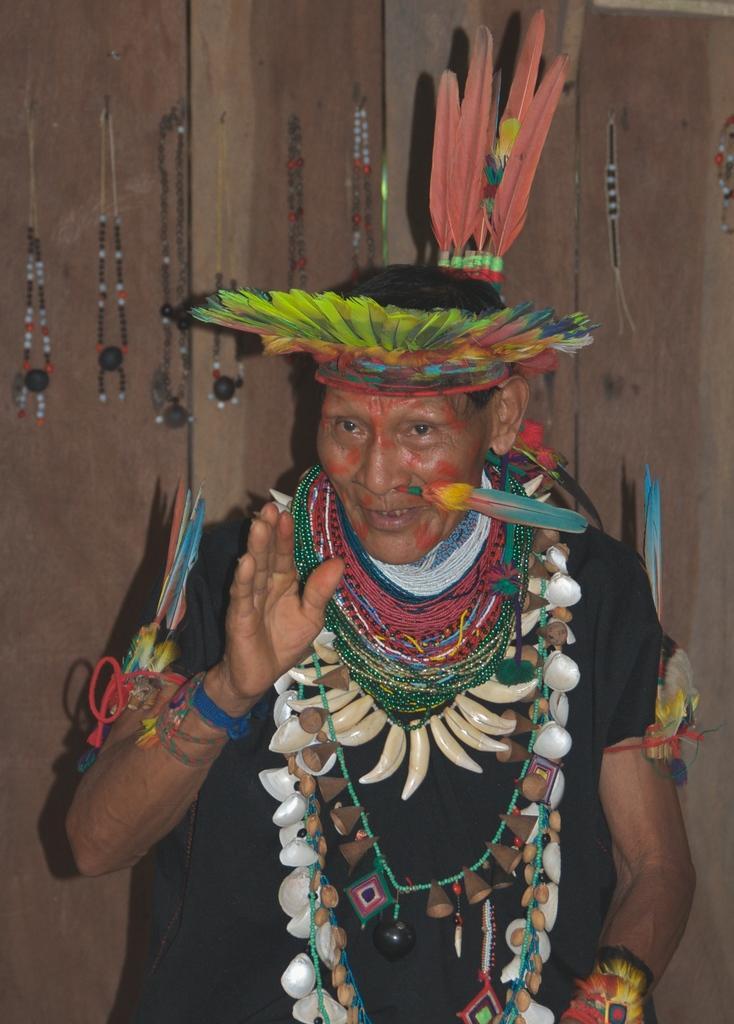How would you summarize this image in a sentence or two? In this image we can see a person wearing a costume, in the background, we can see the wall, on the wall, we can see some chains. 